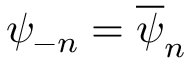<formula> <loc_0><loc_0><loc_500><loc_500>\psi _ { - n } = \overline { \psi } _ { n }</formula> 